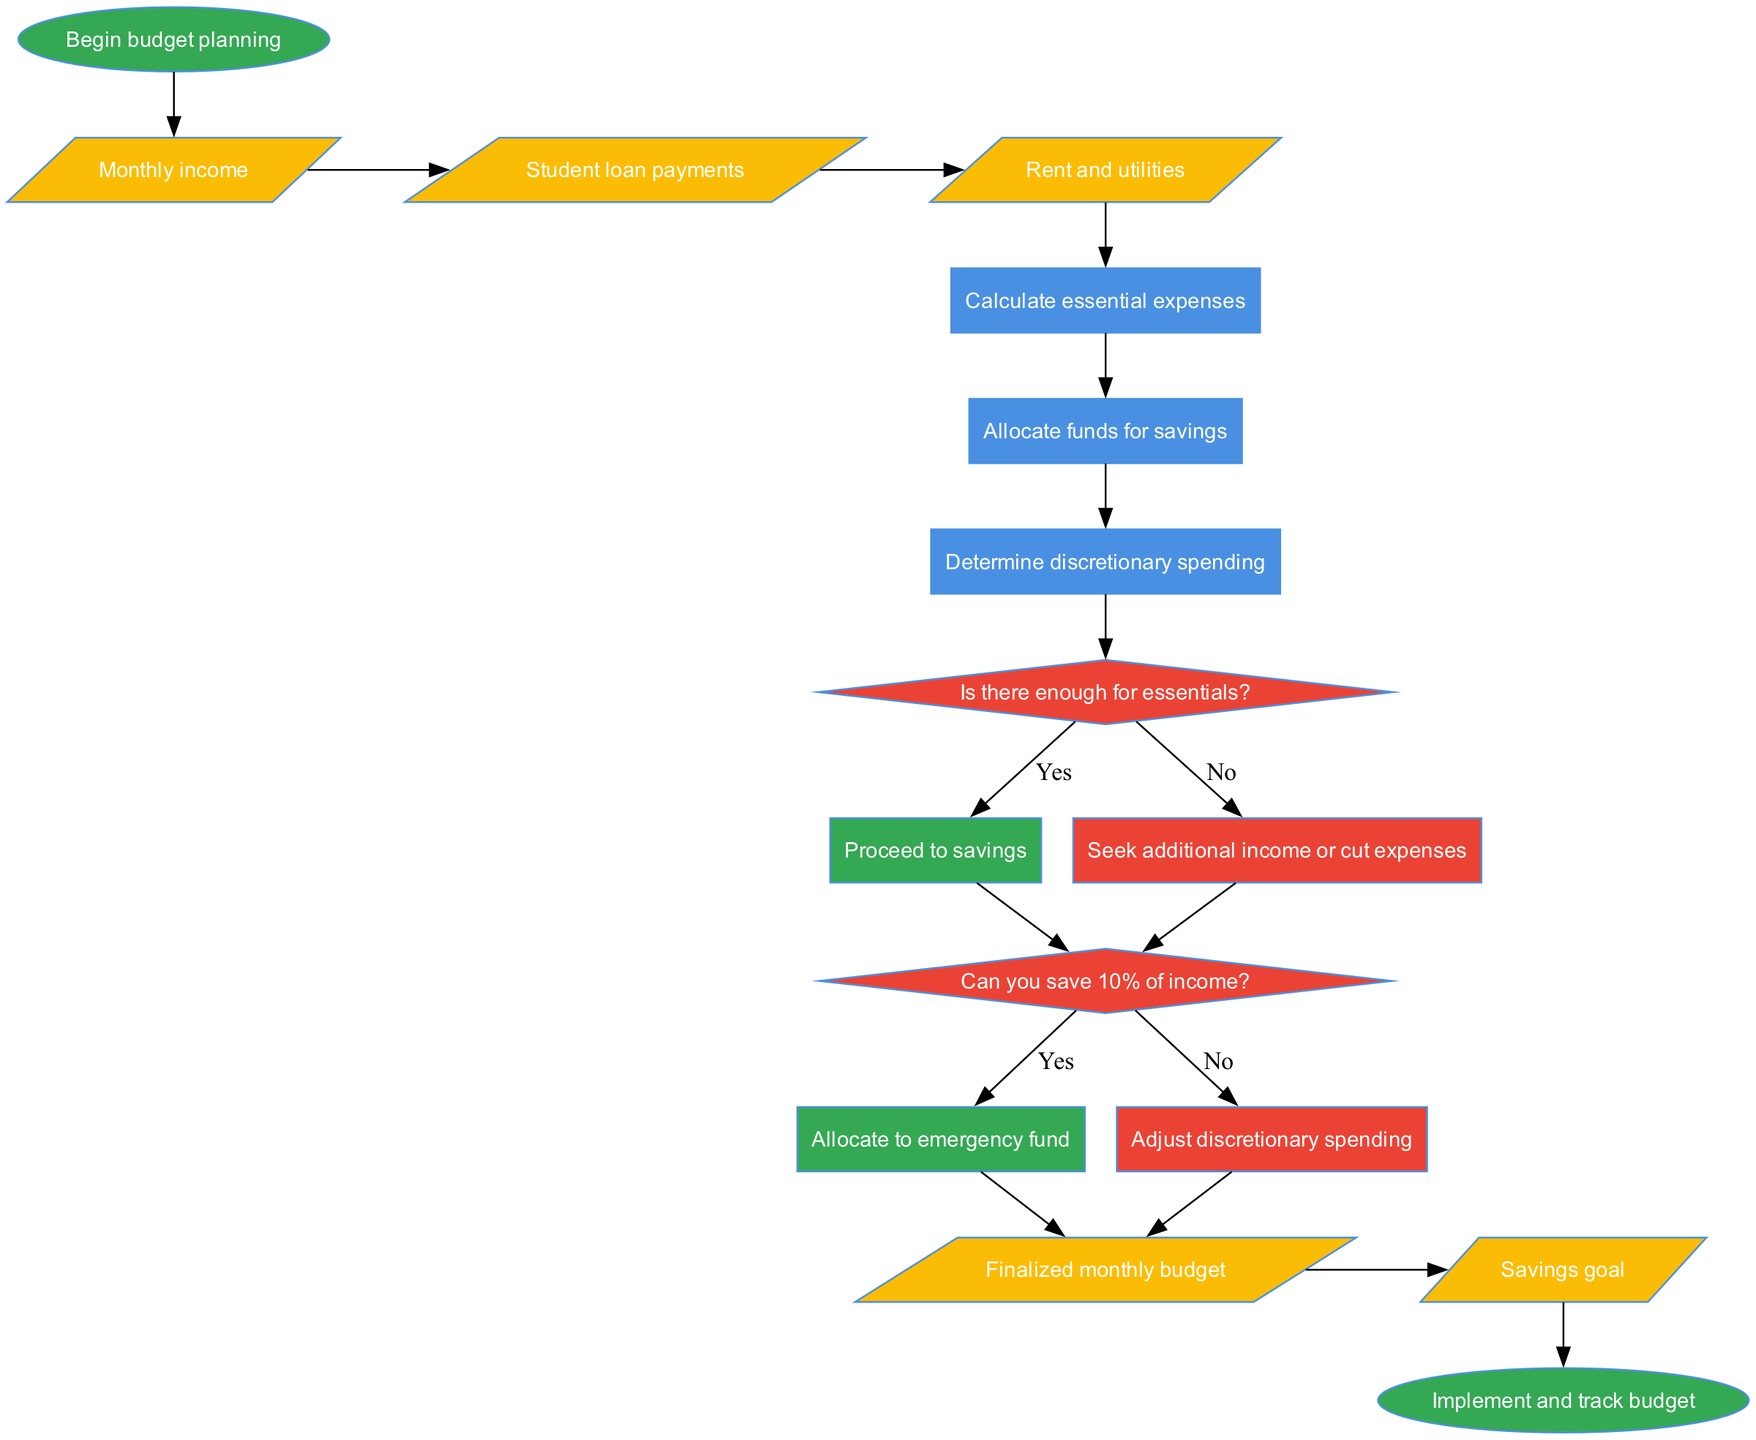What is the starting point of the budget planning process? The starting point is labeled as "Begin budget planning." This is the first node in the diagram, indicating where the process initiates.
Answer: Begin budget planning How many inputs are required for creating the budget? The diagram lists three inputs: "Monthly income," "Student loan payments," and "Rent and utilities." Counting these gives us the total number of required inputs.
Answer: 3 What is the first process after the inputs? The first process is "Calculate essential expenses," which follows the last input node based on the flow sequence in the diagram.
Answer: Calculate essential expenses What happens if there is not enough for essentials? If there is not enough for essentials, the flow goes to "Seek additional income or cut expenses," which is indicated as the outcome from the decision node regarding essential expenses.
Answer: Seek additional income or cut expenses What type of node is "Determine discretionary spending"? "Determine discretionary spending" is classified as a process node, which is identified by its rectangular shape in the diagram.
Answer: Process Can you save 10% of income? This is framed as a decision in the diagram. If the answer is "yes," then the flow goes to "Allocate to emergency fund." If "no," it leads to adjusting discretionary spending. The condition initiates from the first decision node.
Answer: Yes / No What are the outputs of the budgeting process? The outputs are two specific deliverables: "Finalized monthly budget" and "Savings goal." These results follow the last decision outcomes in the flow.
Answer: Finalized monthly budget, Savings goal What is the final step of the budgeting process? The final step is labeled as "Implement and track budget." This signifies the conclusion of the budgeting process and indicates actions taken based upon the finalized budget.
Answer: Implement and track budget What does the flow indicate happens after calculating essential expenses? After calculating essential expenses, the flow proceeds to "Allocate funds for savings," suggesting that savings allocation is the next key action.
Answer: Allocate funds for savings 